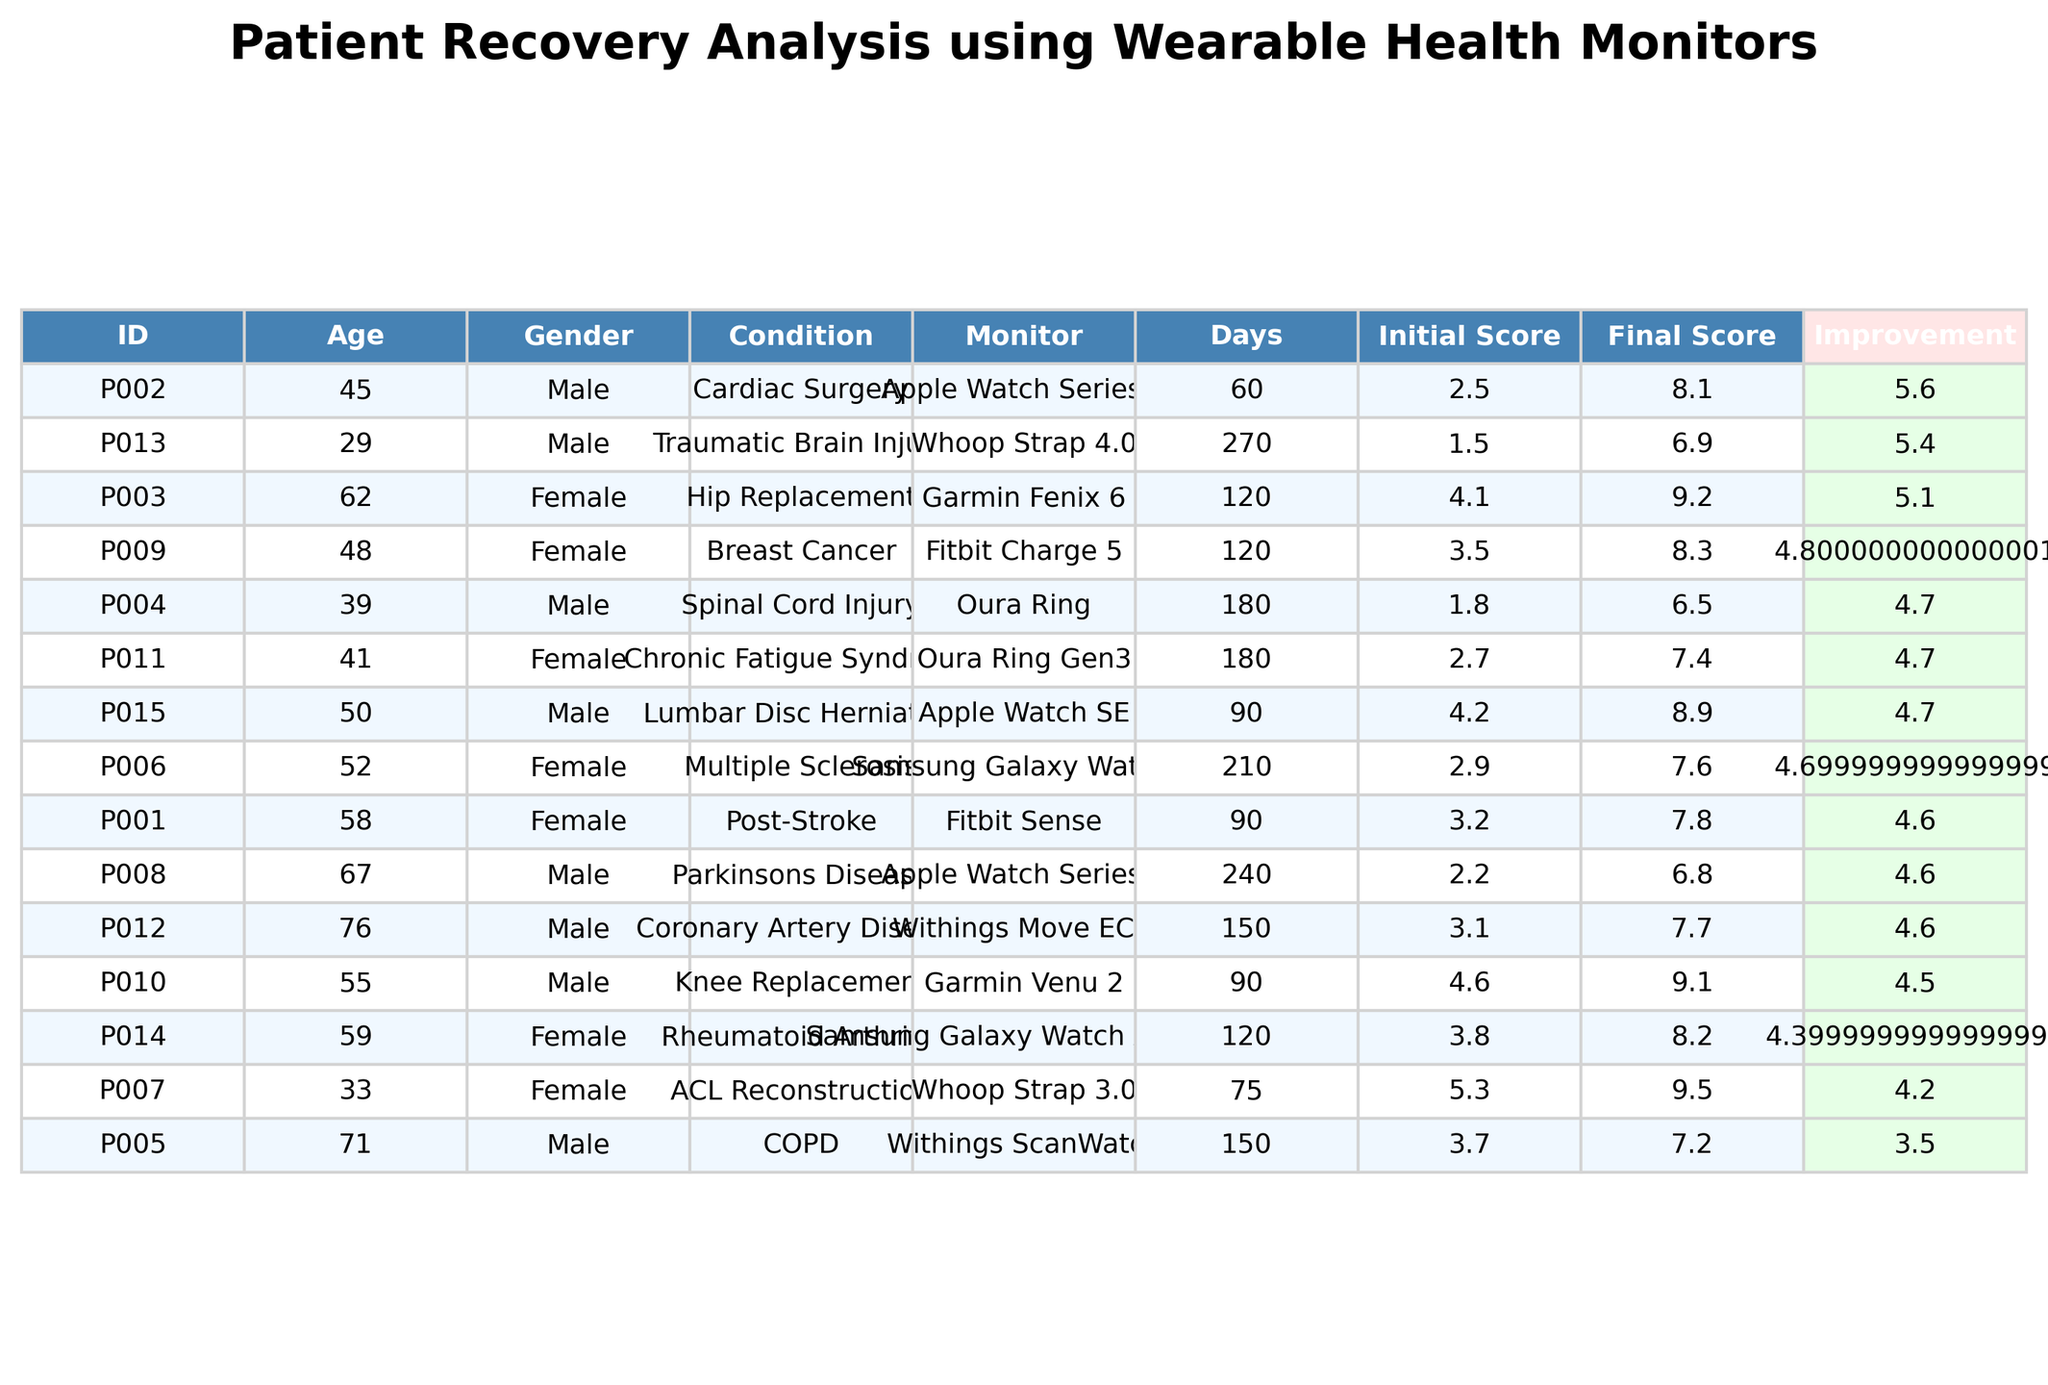What is the highest Final Recovery Score in the table? By scanning the Final Recovery Score column, the highest score observed is 9.5 for patient P007.
Answer: 9.5 Which patient had the lowest Initial Recovery Score? Looking at the Initial Recovery Score column, patient P013 recorded the lowest score of 1.5.
Answer: 1.5 What was the average Daily Steps for all patients? To find the average, sum all Daily Steps and divide by the number of patients: (5623 + 7845 + 4512 + 2134 + 3256 + 4789 + 8912 + 3678 + 6234 + 5987 + 4123 + 2987 + 5678 + 4567 + 6789) / 15 = 4879.2.
Answer: 4879.2 Is there any patient whose Recovery Improvement was negative? By reviewing the Recovery Improvement column, patient P004 has an improvement of -1.3, indicating a negative recovery change.
Answer: Yes Which gender had the patient with the highest Final Recovery Score? Observing the table, the highest Final Recovery Score of 9.5 belongs to a female patient (P007).
Answer: Female What is the total number of days monitored for all patients combined? To find the total, sum the Days Monitored by each patient, which gives (90 + 60 + 120 + 180 + 150 + 210 + 75 + 240 + 120 + 90 + 180 + 150 + 270 + 120 + 90) = 1725.
Answer: 1725 What was the average Recovery Improvement for male patients? First, list the Recovery Improvements for male patients: (5.3, 5.6, 4.2, 1.2, 0.7, 4.0). The average is (5.3 + 5.6 + 4.2 + 1.2 + 0.7 + 4.0) / 6 = 3.67.
Answer: 3.67 How many patients experienced an improvement of 2 or more in their Recovery Scores? Count the Recovery Improvements that are 2 or more: P001, P002, P003, P007, P009, P010, P015 yield a total of 7 patients.
Answer: 7 Which patient had the most Days Monitored and what condition did they have? Looking for the highest value in the Days Monitored column reveals patient P008 with 240 days, diagnosed with Parkinsons Disease.
Answer: P008 with Parkinsons Disease Is there a trend indicating younger patients tend to have higher Final Recovery Scores? Comparing ages with Final Recovery Scores, younger patients P007 (33) and P013 (29) have scores of 9.5 and 6.9 respectively, suggesting a potential trend towards higher scores.
Answer: Yes 